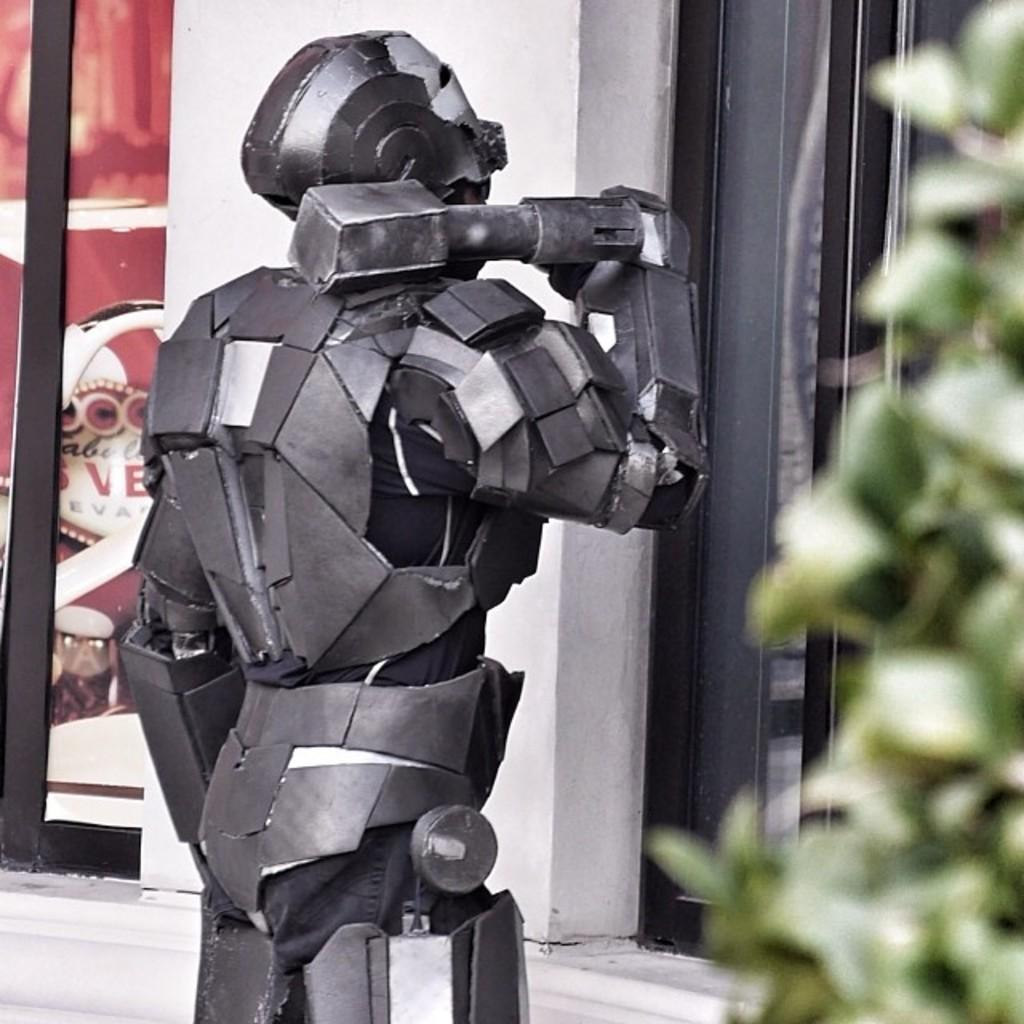What is the main subject of the image? There is a depiction of a person in the center of the image. What can be seen in the background of the image? There is a wall and windows in the background of the image. Are there any plants visible in the image? Yes, there is a plant on the right side of the image. What type of loaf is being used as a prop in the image? There is no loaf present in the image; it features a person, a wall, windows, and a plant. Can you tell me the story behind the person in the image? The image does not provide any information about the person's story or background. 